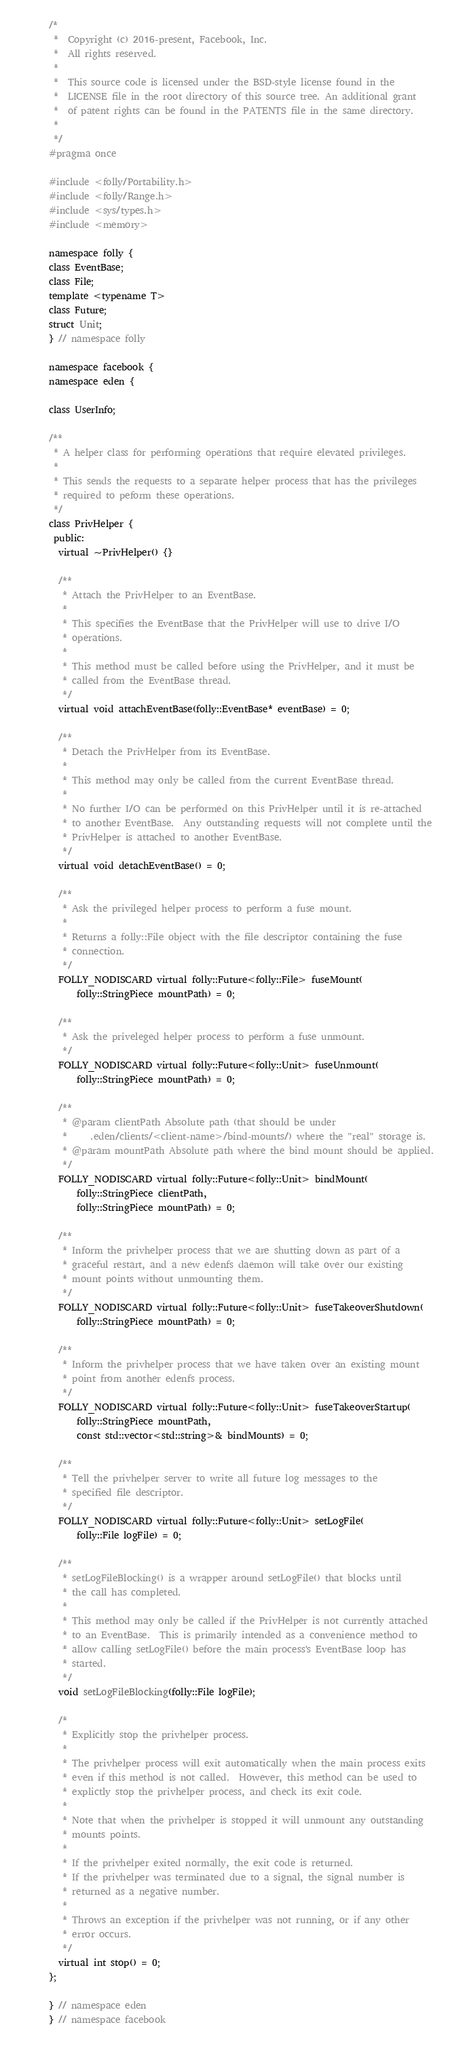<code> <loc_0><loc_0><loc_500><loc_500><_C_>/*
 *  Copyright (c) 2016-present, Facebook, Inc.
 *  All rights reserved.
 *
 *  This source code is licensed under the BSD-style license found in the
 *  LICENSE file in the root directory of this source tree. An additional grant
 *  of patent rights can be found in the PATENTS file in the same directory.
 *
 */
#pragma once

#include <folly/Portability.h>
#include <folly/Range.h>
#include <sys/types.h>
#include <memory>

namespace folly {
class EventBase;
class File;
template <typename T>
class Future;
struct Unit;
} // namespace folly

namespace facebook {
namespace eden {

class UserInfo;

/**
 * A helper class for performing operations that require elevated privileges.
 *
 * This sends the requests to a separate helper process that has the privileges
 * required to peform these operations.
 */
class PrivHelper {
 public:
  virtual ~PrivHelper() {}

  /**
   * Attach the PrivHelper to an EventBase.
   *
   * This specifies the EventBase that the PrivHelper will use to drive I/O
   * operations.
   *
   * This method must be called before using the PrivHelper, and it must be
   * called from the EventBase thread.
   */
  virtual void attachEventBase(folly::EventBase* eventBase) = 0;

  /**
   * Detach the PrivHelper from its EventBase.
   *
   * This method may only be called from the current EventBase thread.
   *
   * No further I/O can be performed on this PrivHelper until it is re-attached
   * to another EventBase.  Any outstanding requests will not complete until the
   * PrivHelper is attached to another EventBase.
   */
  virtual void detachEventBase() = 0;

  /**
   * Ask the privileged helper process to perform a fuse mount.
   *
   * Returns a folly::File object with the file descriptor containing the fuse
   * connection.
   */
  FOLLY_NODISCARD virtual folly::Future<folly::File> fuseMount(
      folly::StringPiece mountPath) = 0;

  /**
   * Ask the priveleged helper process to perform a fuse unmount.
   */
  FOLLY_NODISCARD virtual folly::Future<folly::Unit> fuseUnmount(
      folly::StringPiece mountPath) = 0;

  /**
   * @param clientPath Absolute path (that should be under
   *     .eden/clients/<client-name>/bind-mounts/) where the "real" storage is.
   * @param mountPath Absolute path where the bind mount should be applied.
   */
  FOLLY_NODISCARD virtual folly::Future<folly::Unit> bindMount(
      folly::StringPiece clientPath,
      folly::StringPiece mountPath) = 0;

  /**
   * Inform the privhelper process that we are shutting down as part of a
   * graceful restart, and a new edenfs daemon will take over our existing
   * mount points without unmounting them.
   */
  FOLLY_NODISCARD virtual folly::Future<folly::Unit> fuseTakeoverShutdown(
      folly::StringPiece mountPath) = 0;

  /**
   * Inform the privhelper process that we have taken over an existing mount
   * point from another edenfs process.
   */
  FOLLY_NODISCARD virtual folly::Future<folly::Unit> fuseTakeoverStartup(
      folly::StringPiece mountPath,
      const std::vector<std::string>& bindMounts) = 0;

  /**
   * Tell the privhelper server to write all future log messages to the
   * specified file descriptor.
   */
  FOLLY_NODISCARD virtual folly::Future<folly::Unit> setLogFile(
      folly::File logFile) = 0;

  /**
   * setLogFileBlocking() is a wrapper around setLogFile() that blocks until
   * the call has completed.
   *
   * This method may only be called if the PrivHelper is not currently attached
   * to an EventBase.  This is primarily intended as a convenience method to
   * allow calling setLogFile() before the main process's EventBase loop has
   * started.
   */
  void setLogFileBlocking(folly::File logFile);

  /*
   * Explicitly stop the privhelper process.
   *
   * The privhelper process will exit automatically when the main process exits
   * even if this method is not called.  However, this method can be used to
   * explictly stop the privhelper process, and check its exit code.
   *
   * Note that when the privhelper is stopped it will unmount any outstanding
   * mounts points.
   *
   * If the privhelper exited normally, the exit code is returned.
   * If the privhelper was terminated due to a signal, the signal number is
   * returned as a negative number.
   *
   * Throws an exception if the privhelper was not running, or if any other
   * error occurs.
   */
  virtual int stop() = 0;
};

} // namespace eden
} // namespace facebook
</code> 